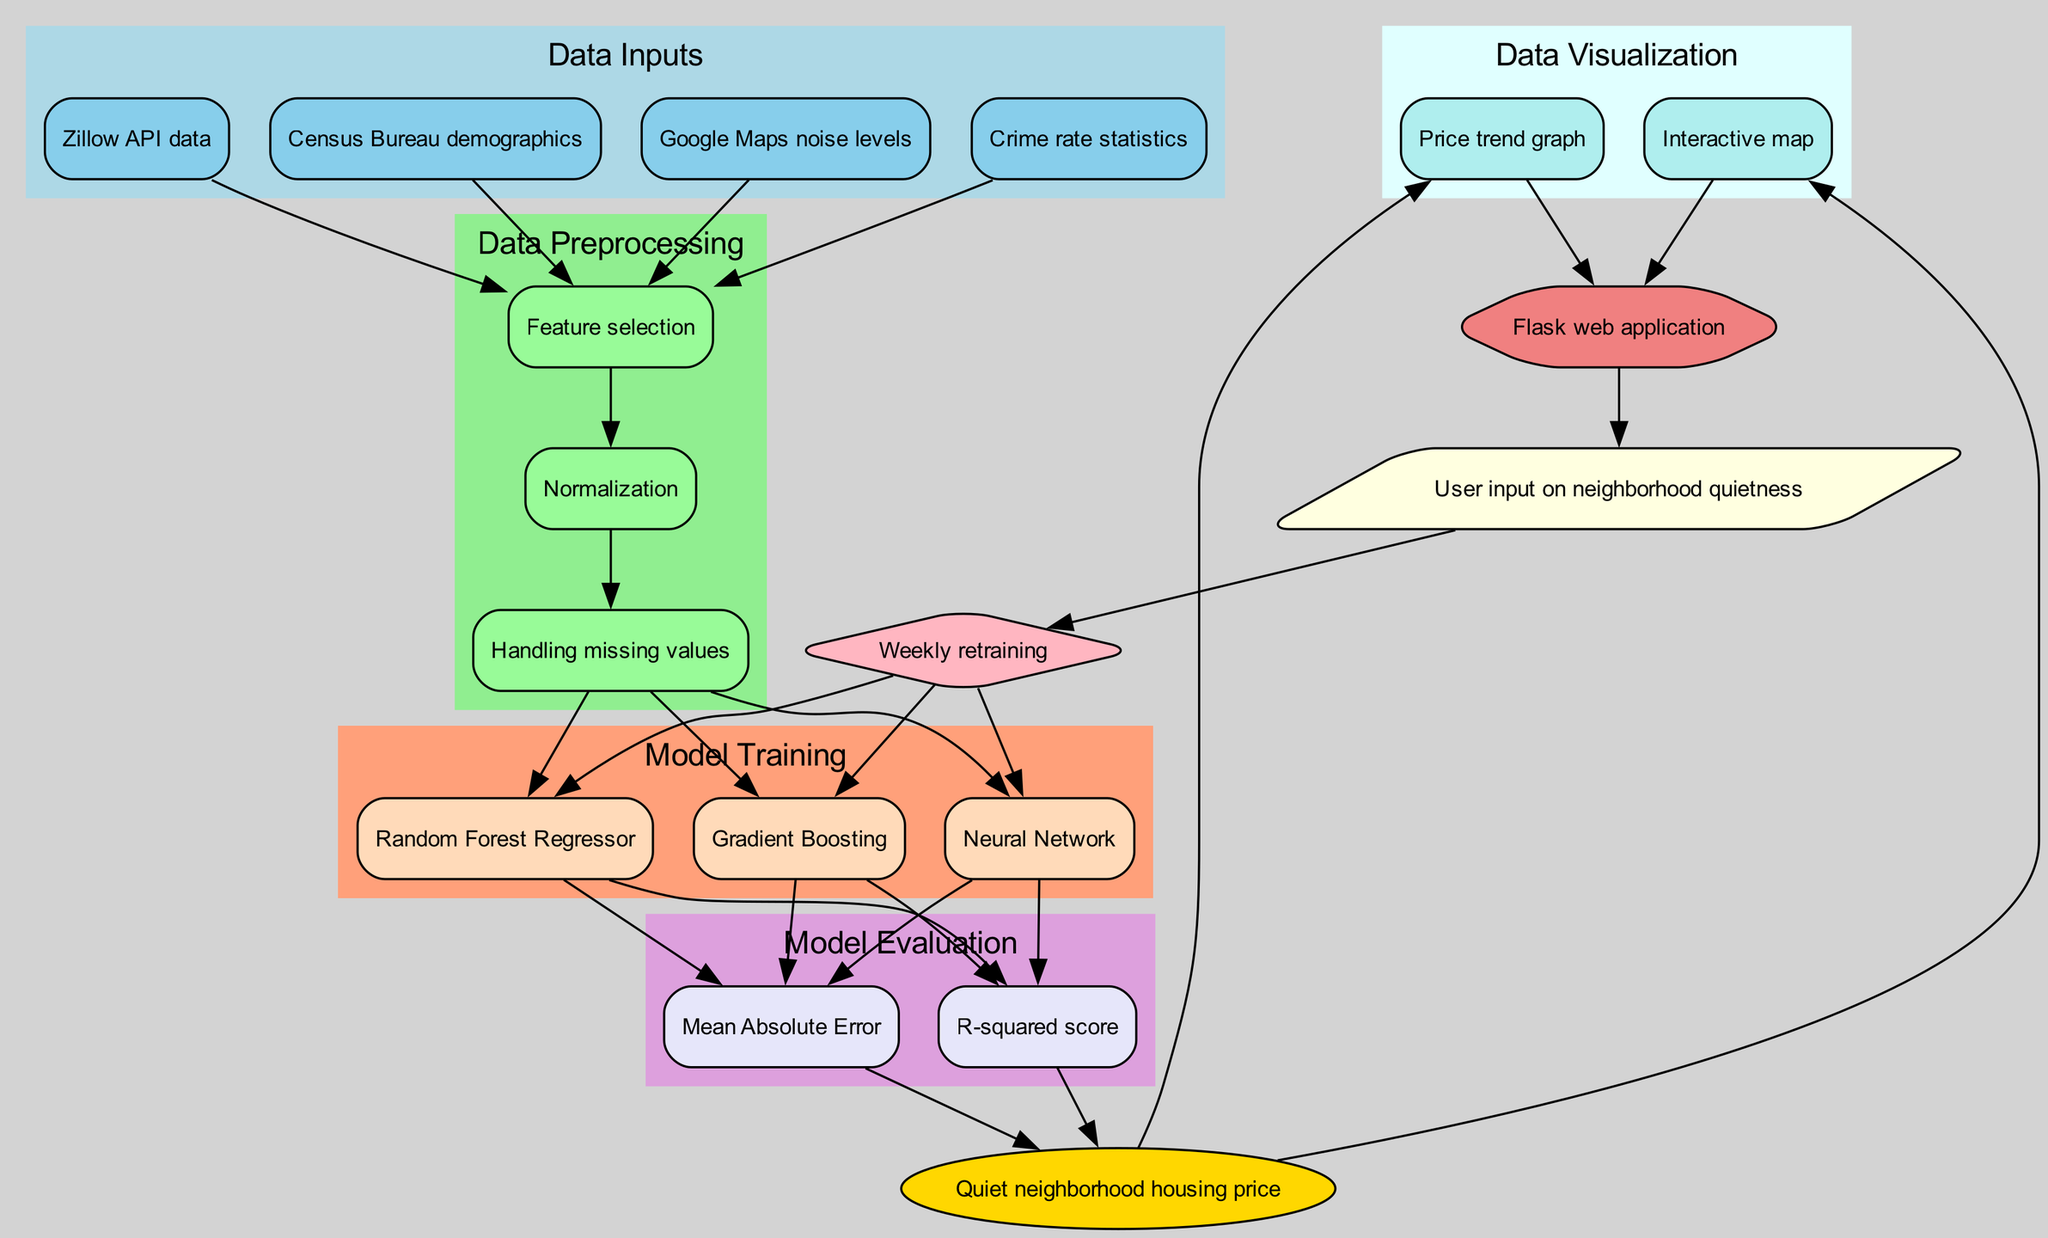What are the data inputs used in this pipeline? The diagram specifies four data inputs: Zillow API data, Census Bureau demographics, Google Maps noise levels, and Crime rate statistics.
Answer: Zillow API data, Census Bureau demographics, Google Maps noise levels, Crime rate statistics Which models are being trained in the model training phase? The diagram indicates three models that are being trained: Random Forest Regressor, Gradient Boosting, and Neural Network.
Answer: Random Forest Regressor, Gradient Boosting, Neural Network How many steps are there in the data preprocessing phase? The diagram shows three steps in the data preprocessing phase: Feature selection, Normalization, and Handling missing values.
Answer: 3 What is the prediction output of this pipeline? The diagram states that the prediction output is for the Quiet neighborhood housing price.
Answer: Quiet neighborhood housing price Which evaluation metrics are used to assess the model? Viewing the diagram, we can see that the evaluation metrics used are Mean Absolute Error and R-squared score.
Answer: Mean Absolute Error, R-squared score What is the final step after Deployment in the diagram? According to the diagram, the final step after Deployment is Feedback, which implies gathering user input on neighborhood quietness.
Answer: Feedback How does the model update process occur? The diagram indicates that the model updating process involves weekly retraining of the models specified in the model training phase.
Answer: Weekly retraining Which visualization tools are mentioned in the data visualization phase? The diagram indicates two visualization tools: Interactive map and Price trend graph are utilized to visualize the predictions.
Answer: Interactive map, Price trend graph What kind of application is this pipeline deployed as? The diagram specifies that the deployment method for this pipeline is as a Flask web application.
Answer: Flask web application 